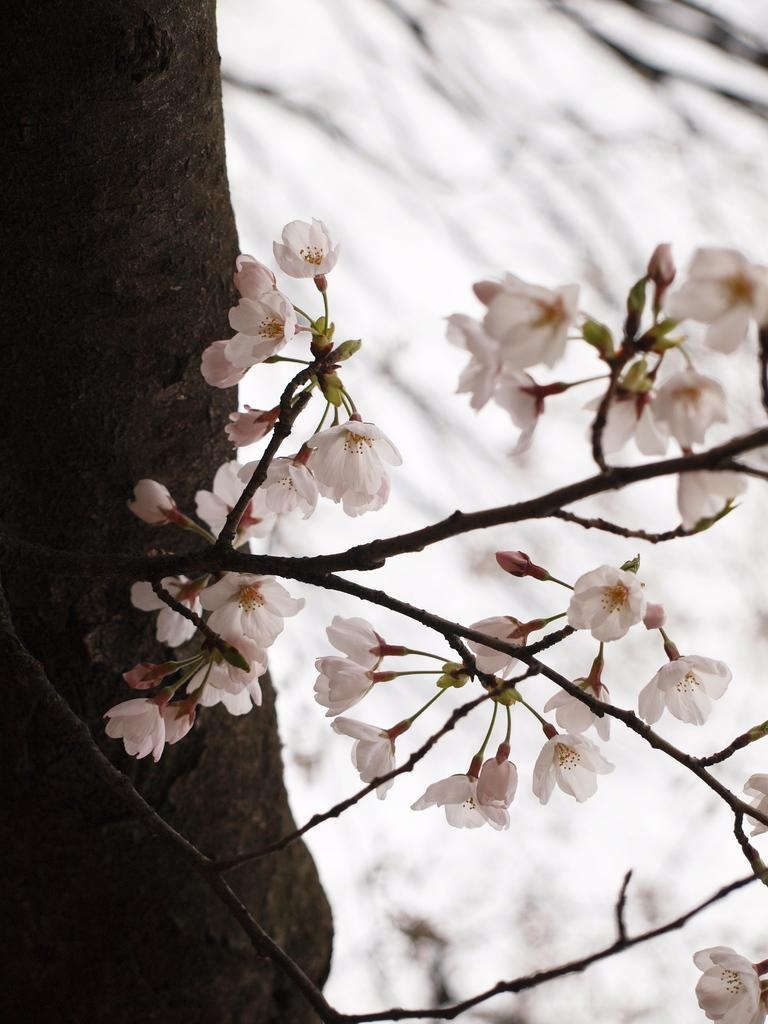What type of flowers can be seen on the branch in the image? There are small white color flowers on the branch in the image. What part of the tree is visible in the image? There is a tree trunk visible in the image. How would you describe the background of the image? The background of the image is blurred. How many nails are used to hold the cracker in the tree trunk together in the image? There are no nails or cracks in the tree trunk visible in the image. Are there any women present in the image? There is no mention of women in the provided facts, and therefore no women are present in the image. 